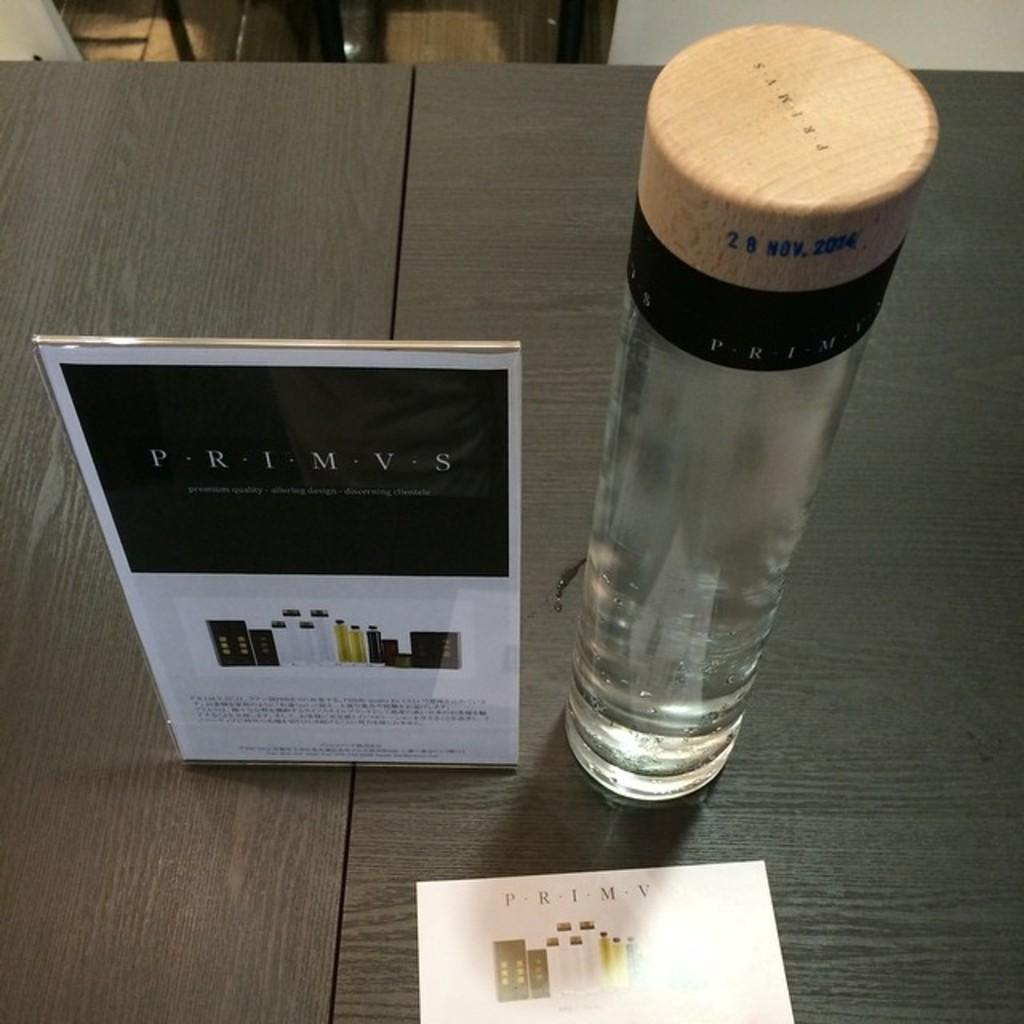Provide a one-sentence caption for the provided image. A glass container is next to an advertisement for Primvs. 